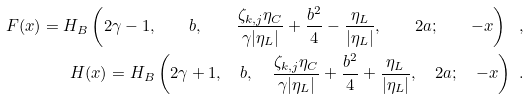Convert formula to latex. <formula><loc_0><loc_0><loc_500><loc_500>F ( x ) = H _ { B } \left ( 2 \gamma - 1 , \quad b , \quad \frac { \zeta _ { k , j } \eta _ { C } } { \gamma | \eta _ { L } | } + \frac { b ^ { 2 } } { 4 } - \frac { \eta _ { L } } { | \eta _ { L } | } , \quad 2 a ; \quad - x \right ) \ , \\ H ( x ) = H _ { B } \left ( 2 \gamma + 1 , \quad b , \quad \frac { \zeta _ { k , j } \eta _ { C } } { \gamma | \eta _ { L } | } + \frac { b ^ { 2 } } { 4 } + \frac { \eta _ { L } } { | \eta _ { L } | } , \quad 2 a ; \quad - x \right ) \ .</formula> 